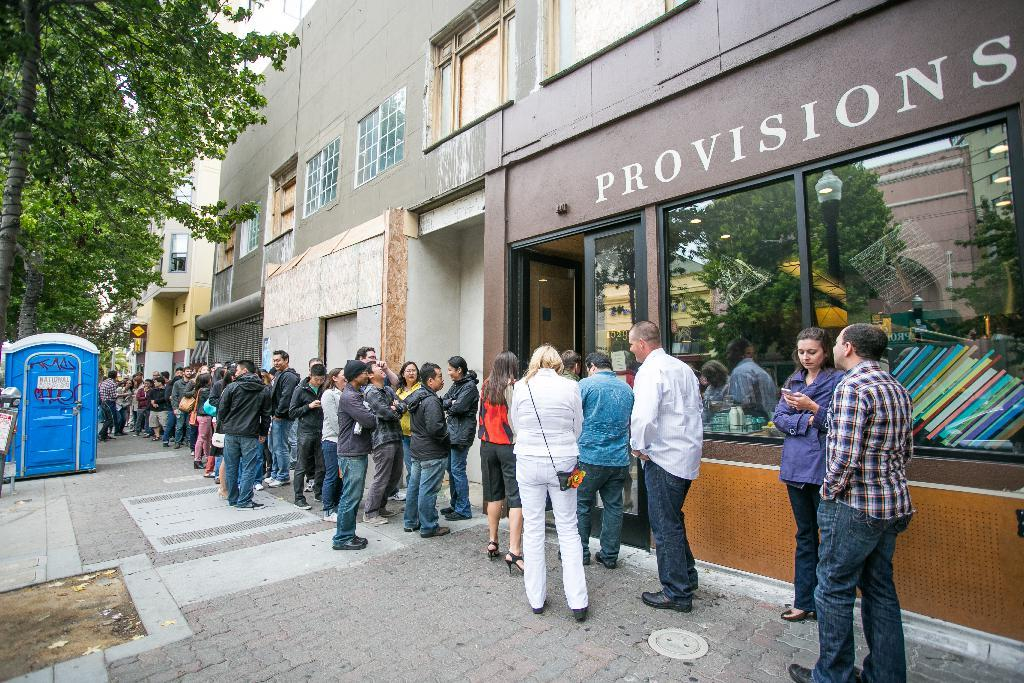What type of structures can be seen in the image? There are buildings in the image. What other elements can be found in the image besides buildings? There are trees, a banner, a door, windows, and people standing in the image. Can you describe the banner in the image? The banner is a long strip of material with a message or design on it. How many people are visible in the image? There are people standing in the image, but the exact number cannot be determined from the provided facts. What type of apple is being used as a decoration on the train in the image? There is no train or apple present in the image; it features buildings, trees, a banner, a door, windows, and people standing. 